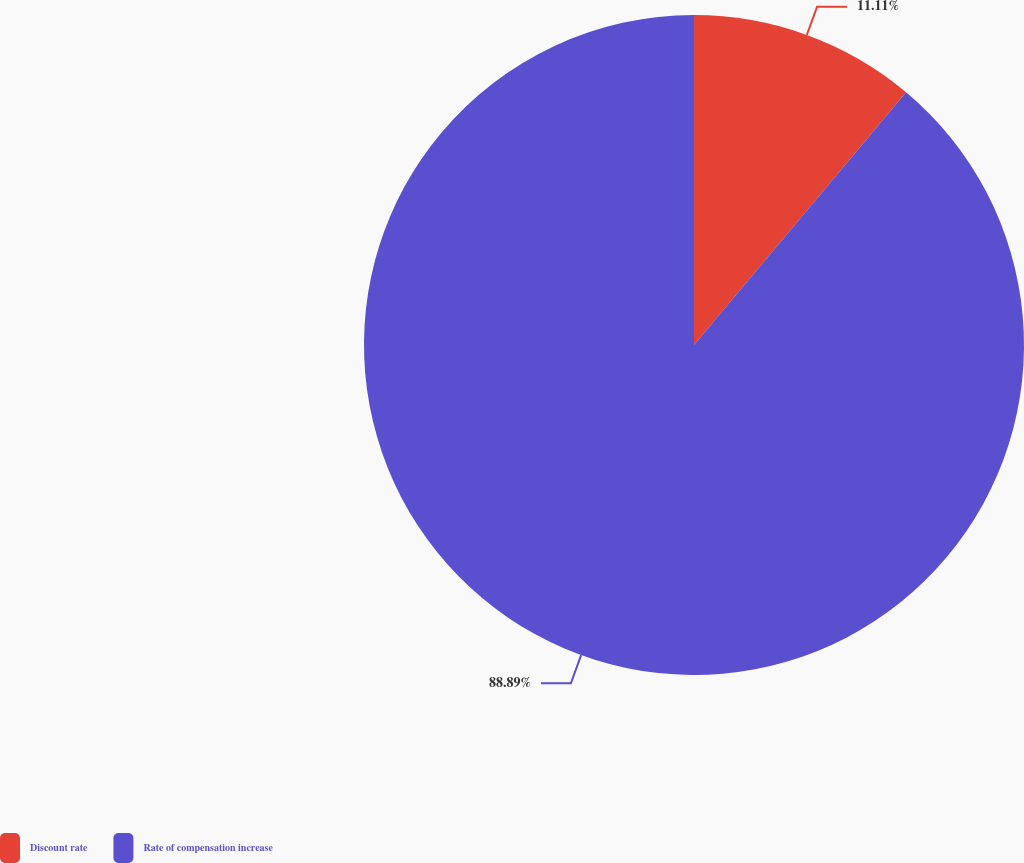Convert chart. <chart><loc_0><loc_0><loc_500><loc_500><pie_chart><fcel>Discount rate<fcel>Rate of compensation increase<nl><fcel>11.11%<fcel>88.89%<nl></chart> 